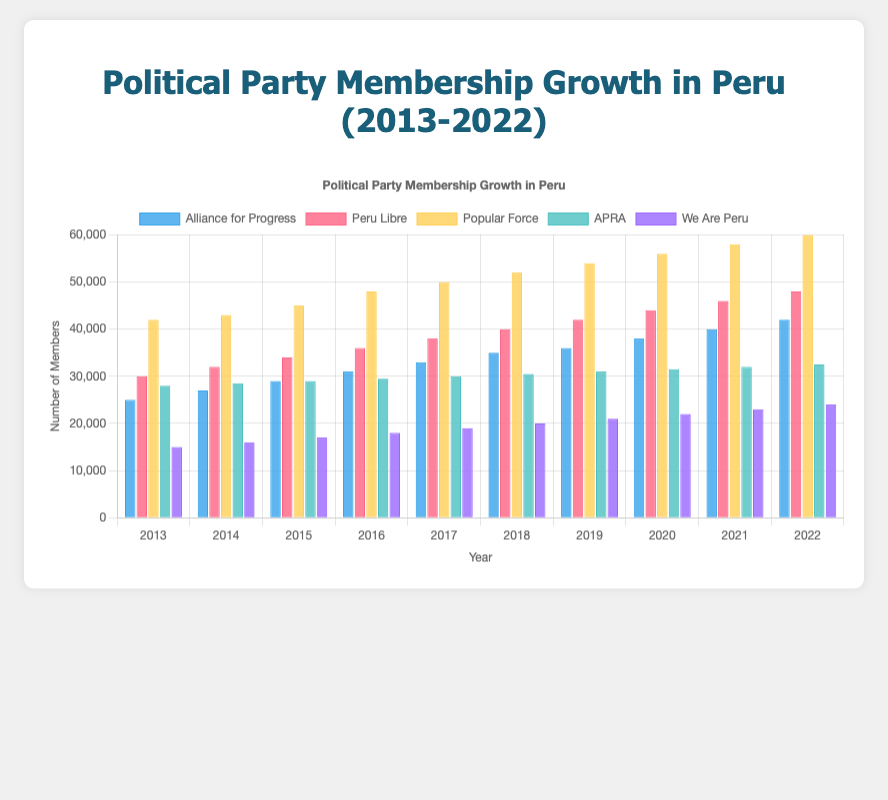What's the average membership of Alliance for Progress from 2013 to 2022? Sum the membership numbers for Alliance for Progress from 2013 (25000) to 2022 (42000) which is 25000 + 27000 + 29000 + 31000 + 33000 + 35000 + 36000 + 38000 + 40000 + 42000 = 336000. Divide this sum by the number of years (10). Hence, the average membership is 336000 / 10 = 33600.
Answer: 33600 Which party had the highest membership in 2022? Refer to the bar heights for 2022. The Popular Force has the highest bar representing 60000 members.
Answer: Popular Force How did the membership of Peru Libre change from 2018 to 2022? Check Peru Libre's bars for 2018 (40000) and 2022 (48000). The change in membership is 48000 - 40000 = 8000.
Answer: Increased by 8000 Which party showed the most consistent growth over the decade? Compare the growth trends of all parties. Alliance for Progress shows a steady increase every year from 25000 in 2013 to 42000 in 2022.
Answer: Alliance for Progress In which year did Alliance for Progress surpass 30000 members? Look at the membership numbers for Alliance for Progress. It surpassed 30000 in 2016 with a membership of 31000.
Answer: 2016 Calculate the total membership of all parties in 2017. Sum the memberships for each party in 2017: Alliance for Progress (33000) + Peru Libre (38000) + Popular Force (50000) + APRA (30000) + We Are Peru (19000) = 170000.
Answer: 170000 What is the percentage increase in membership for We Are Peru from 2015 to 2022? The membership for We Are Peru in 2015 was 17000 and in 2022 it was 24000. The increase is 24000 - 17000 = 7000. The percentage increase is (7000 / 17000) * 100 ≈ 41.18%.
Answer: 41.18% By how much did Popular Force's membership grow between 2016 and 2019? The membership of Popular Force in 2016 was 48000, and in 2019 it was 54000. The growth is 54000 - 48000 = 6000.
Answer: 6000 Which party had the least increase in membership from 2013 to 2022? Calculate the increase for each party and compare. Alliance for Progress: 42000-25000=17000, Peru Libre: 48000-30000=18000, Popular Force: 60000-42000=18000, APRA: 32500-28000=4500, We Are Peru: 24000-15000=9000. APRA has the least increase with 4500.
Answer: APRA 